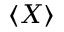<formula> <loc_0><loc_0><loc_500><loc_500>\langle X \rangle</formula> 